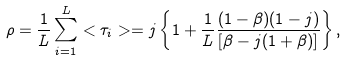<formula> <loc_0><loc_0><loc_500><loc_500>\rho = \frac { 1 } { L } \sum ^ { L } _ { i = 1 } < \tau _ { i } > = j \left \{ 1 + \frac { 1 } { L } \frac { ( 1 - \beta ) ( 1 - j ) } { [ \beta - j ( 1 + \beta ) ] } \right \} ,</formula> 